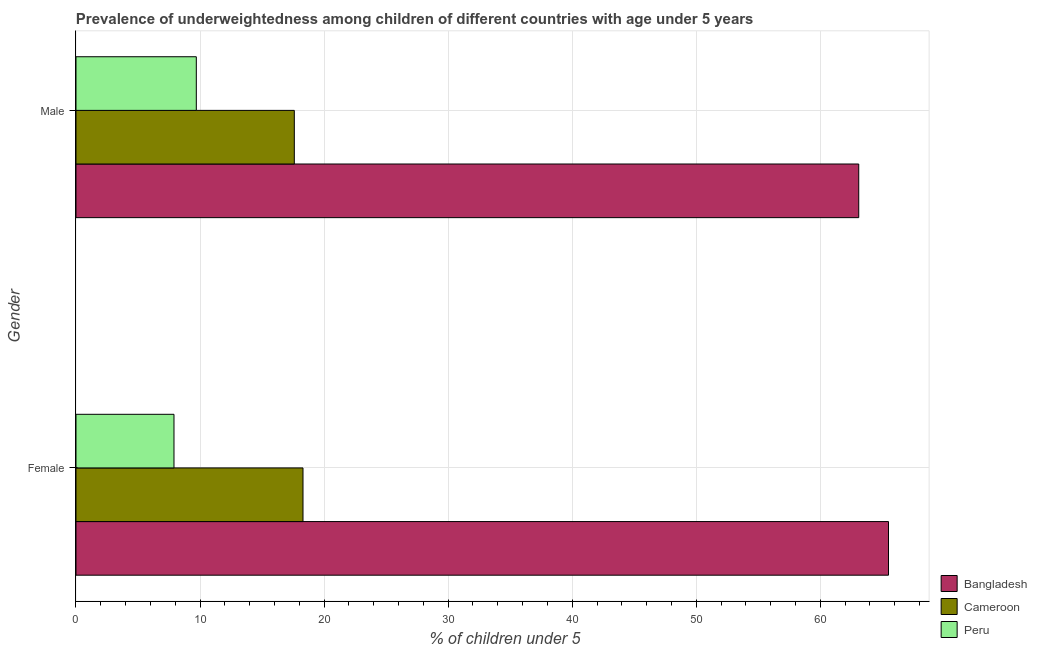How many groups of bars are there?
Keep it short and to the point. 2. Are the number of bars on each tick of the Y-axis equal?
Your response must be concise. Yes. How many bars are there on the 1st tick from the top?
Offer a terse response. 3. How many bars are there on the 1st tick from the bottom?
Provide a succinct answer. 3. What is the percentage of underweighted male children in Cameroon?
Your answer should be very brief. 17.6. Across all countries, what is the maximum percentage of underweighted male children?
Your response must be concise. 63.1. Across all countries, what is the minimum percentage of underweighted female children?
Give a very brief answer. 7.9. What is the total percentage of underweighted female children in the graph?
Give a very brief answer. 91.7. What is the difference between the percentage of underweighted female children in Cameroon and that in Peru?
Make the answer very short. 10.4. What is the difference between the percentage of underweighted female children in Cameroon and the percentage of underweighted male children in Peru?
Your answer should be very brief. 8.6. What is the average percentage of underweighted male children per country?
Offer a terse response. 30.13. What is the difference between the percentage of underweighted female children and percentage of underweighted male children in Bangladesh?
Ensure brevity in your answer.  2.4. What is the ratio of the percentage of underweighted female children in Bangladesh to that in Peru?
Offer a terse response. 8.29. What does the 2nd bar from the top in Male represents?
Provide a short and direct response. Cameroon. What does the 2nd bar from the bottom in Female represents?
Your answer should be compact. Cameroon. How many bars are there?
Give a very brief answer. 6. How many countries are there in the graph?
Offer a terse response. 3. Does the graph contain any zero values?
Keep it short and to the point. No. Does the graph contain grids?
Your response must be concise. Yes. Where does the legend appear in the graph?
Your answer should be compact. Bottom right. What is the title of the graph?
Keep it short and to the point. Prevalence of underweightedness among children of different countries with age under 5 years. Does "Middle income" appear as one of the legend labels in the graph?
Ensure brevity in your answer.  No. What is the label or title of the X-axis?
Provide a succinct answer.  % of children under 5. What is the  % of children under 5 of Bangladesh in Female?
Make the answer very short. 65.5. What is the  % of children under 5 in Cameroon in Female?
Ensure brevity in your answer.  18.3. What is the  % of children under 5 in Peru in Female?
Make the answer very short. 7.9. What is the  % of children under 5 in Bangladesh in Male?
Make the answer very short. 63.1. What is the  % of children under 5 of Cameroon in Male?
Provide a succinct answer. 17.6. What is the  % of children under 5 of Peru in Male?
Keep it short and to the point. 9.7. Across all Gender, what is the maximum  % of children under 5 of Bangladesh?
Offer a very short reply. 65.5. Across all Gender, what is the maximum  % of children under 5 in Cameroon?
Provide a short and direct response. 18.3. Across all Gender, what is the maximum  % of children under 5 of Peru?
Your answer should be compact. 9.7. Across all Gender, what is the minimum  % of children under 5 in Bangladesh?
Offer a very short reply. 63.1. Across all Gender, what is the minimum  % of children under 5 of Cameroon?
Keep it short and to the point. 17.6. Across all Gender, what is the minimum  % of children under 5 in Peru?
Your response must be concise. 7.9. What is the total  % of children under 5 of Bangladesh in the graph?
Offer a terse response. 128.6. What is the total  % of children under 5 of Cameroon in the graph?
Provide a succinct answer. 35.9. What is the total  % of children under 5 of Peru in the graph?
Your response must be concise. 17.6. What is the difference between the  % of children under 5 of Bangladesh in Female and that in Male?
Offer a terse response. 2.4. What is the difference between the  % of children under 5 of Cameroon in Female and that in Male?
Offer a terse response. 0.7. What is the difference between the  % of children under 5 in Bangladesh in Female and the  % of children under 5 in Cameroon in Male?
Make the answer very short. 47.9. What is the difference between the  % of children under 5 in Bangladesh in Female and the  % of children under 5 in Peru in Male?
Give a very brief answer. 55.8. What is the difference between the  % of children under 5 in Cameroon in Female and the  % of children under 5 in Peru in Male?
Your response must be concise. 8.6. What is the average  % of children under 5 of Bangladesh per Gender?
Offer a very short reply. 64.3. What is the average  % of children under 5 of Cameroon per Gender?
Make the answer very short. 17.95. What is the difference between the  % of children under 5 of Bangladesh and  % of children under 5 of Cameroon in Female?
Provide a short and direct response. 47.2. What is the difference between the  % of children under 5 in Bangladesh and  % of children under 5 in Peru in Female?
Your answer should be compact. 57.6. What is the difference between the  % of children under 5 of Bangladesh and  % of children under 5 of Cameroon in Male?
Make the answer very short. 45.5. What is the difference between the  % of children under 5 in Bangladesh and  % of children under 5 in Peru in Male?
Your answer should be compact. 53.4. What is the ratio of the  % of children under 5 in Bangladesh in Female to that in Male?
Your response must be concise. 1.04. What is the ratio of the  % of children under 5 of Cameroon in Female to that in Male?
Provide a succinct answer. 1.04. What is the ratio of the  % of children under 5 in Peru in Female to that in Male?
Keep it short and to the point. 0.81. What is the difference between the highest and the second highest  % of children under 5 in Bangladesh?
Keep it short and to the point. 2.4. What is the difference between the highest and the second highest  % of children under 5 of Cameroon?
Keep it short and to the point. 0.7. What is the difference between the highest and the lowest  % of children under 5 of Peru?
Offer a very short reply. 1.8. 